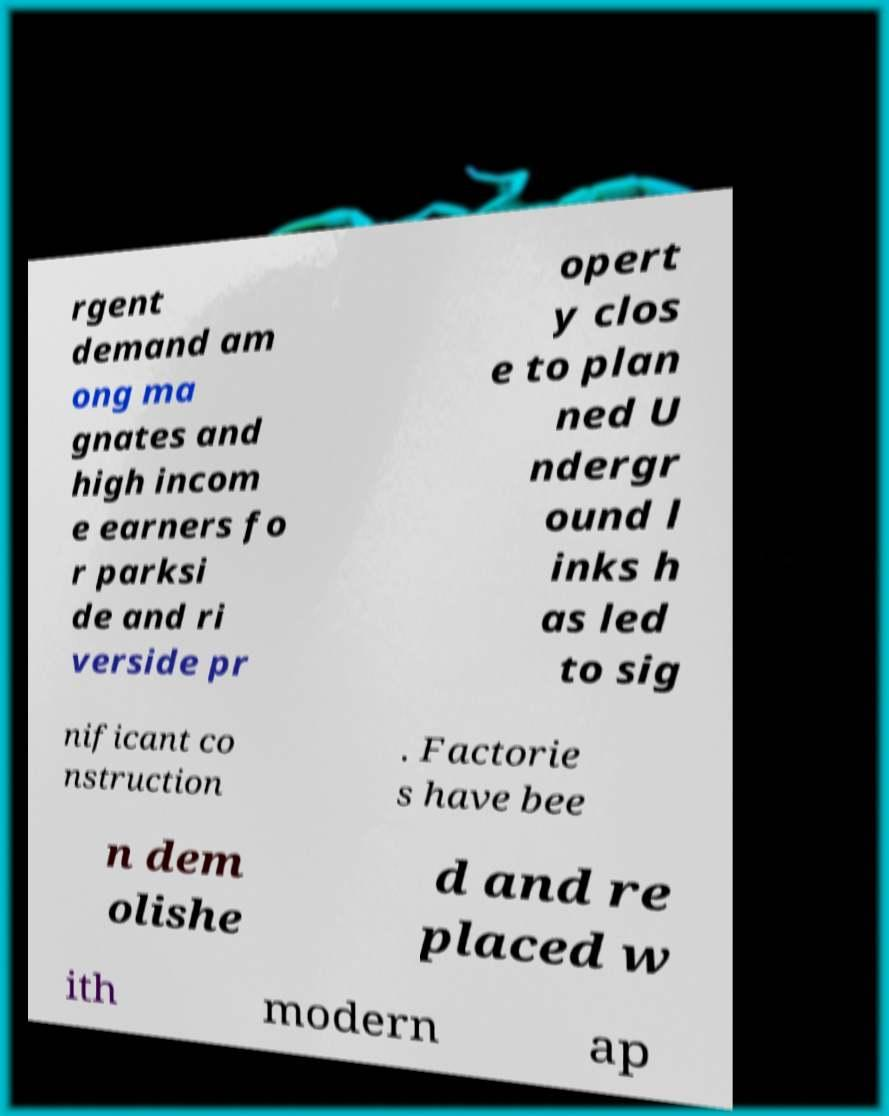Could you assist in decoding the text presented in this image and type it out clearly? rgent demand am ong ma gnates and high incom e earners fo r parksi de and ri verside pr opert y clos e to plan ned U ndergr ound l inks h as led to sig nificant co nstruction . Factorie s have bee n dem olishe d and re placed w ith modern ap 